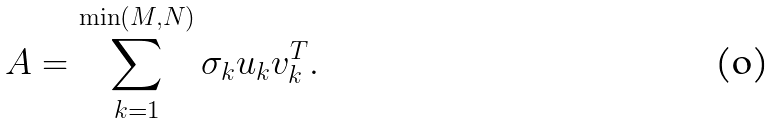<formula> <loc_0><loc_0><loc_500><loc_500>A = \sum _ { k = 1 } ^ { \min ( M , N ) } \sigma _ { k } u _ { k } v _ { k } ^ { T } .</formula> 